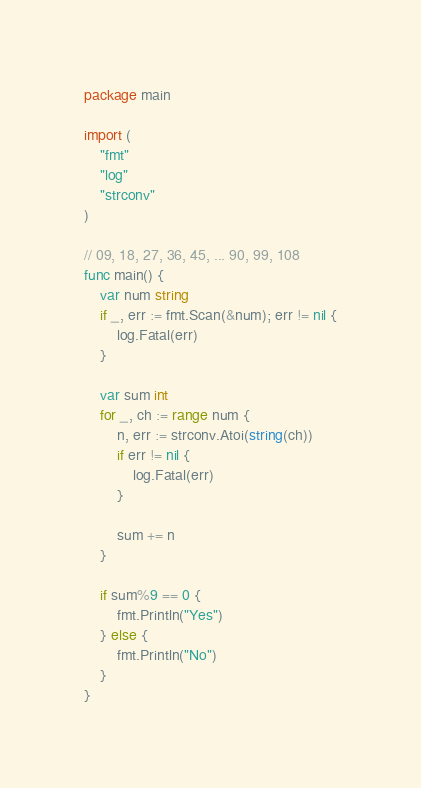Convert code to text. <code><loc_0><loc_0><loc_500><loc_500><_Go_>package main

import (
	"fmt"
	"log"
	"strconv"
)

// 09, 18, 27, 36, 45, ... 90, 99, 108
func main() {
	var num string
	if _, err := fmt.Scan(&num); err != nil {
		log.Fatal(err)
	}

	var sum int
	for _, ch := range num {
		n, err := strconv.Atoi(string(ch))
		if err != nil {
			log.Fatal(err)
		}

		sum += n
	}

	if sum%9 == 0 {
		fmt.Println("Yes")
	} else {
		fmt.Println("No")
	}
}
</code> 